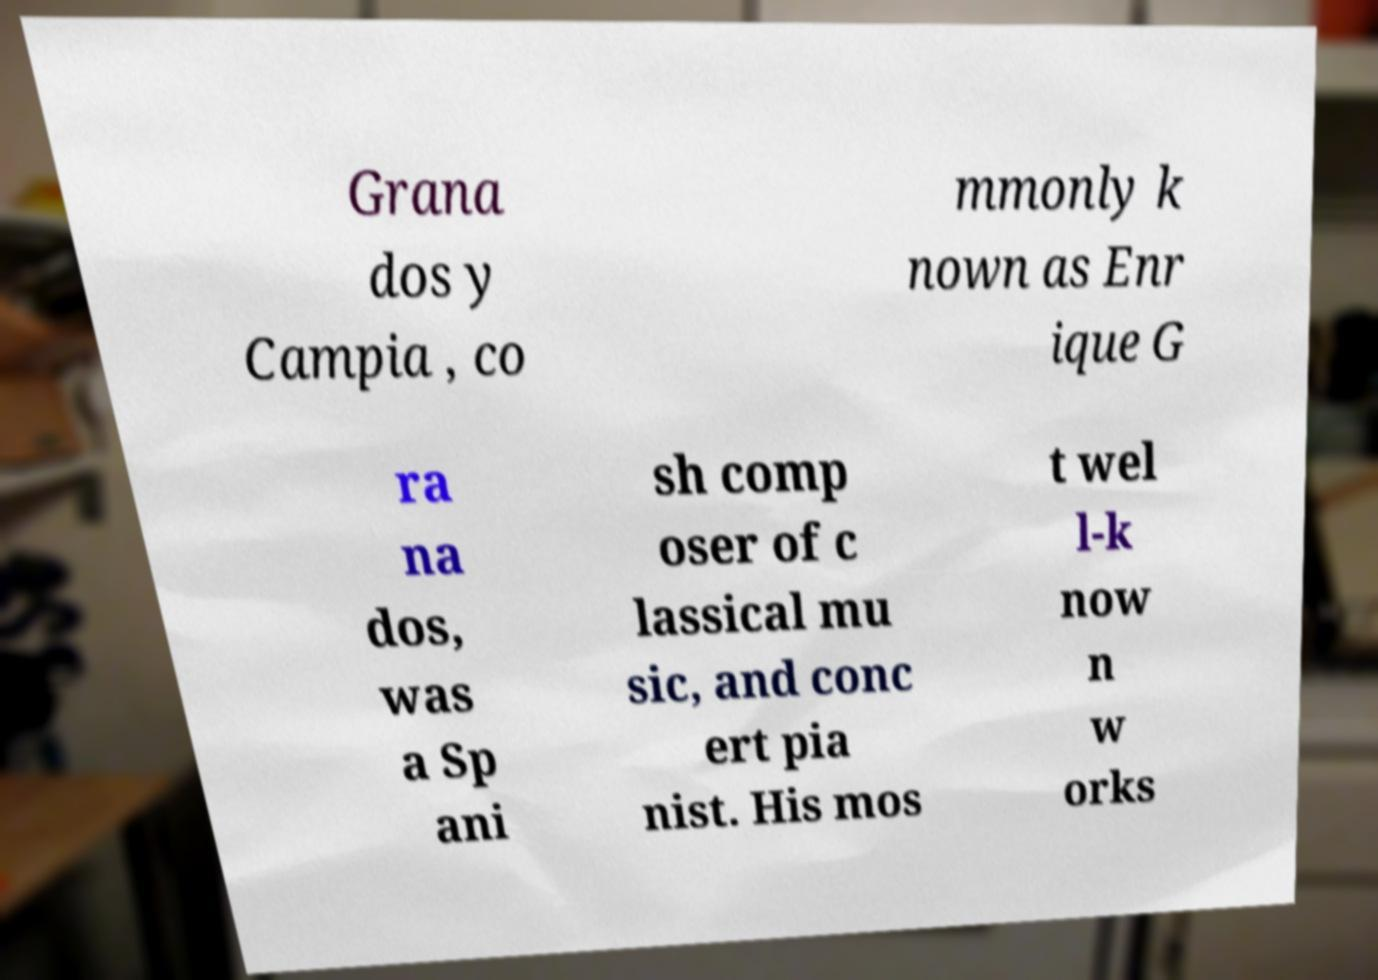Can you accurately transcribe the text from the provided image for me? Grana dos y Campia , co mmonly k nown as Enr ique G ra na dos, was a Sp ani sh comp oser of c lassical mu sic, and conc ert pia nist. His mos t wel l-k now n w orks 